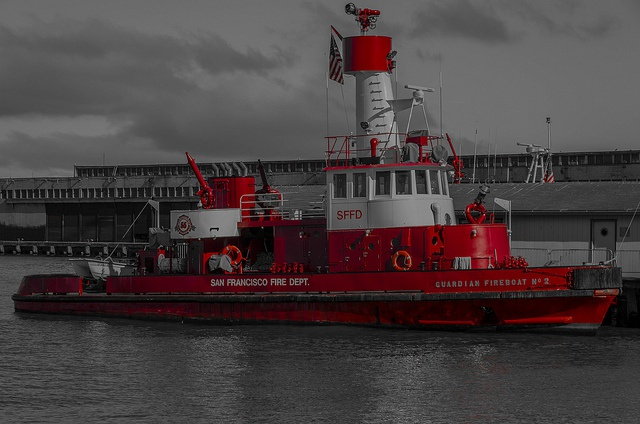Describe the objects in this image and their specific colors. I can see boat in gray, black, and maroon tones and boat in gray and black tones in this image. 